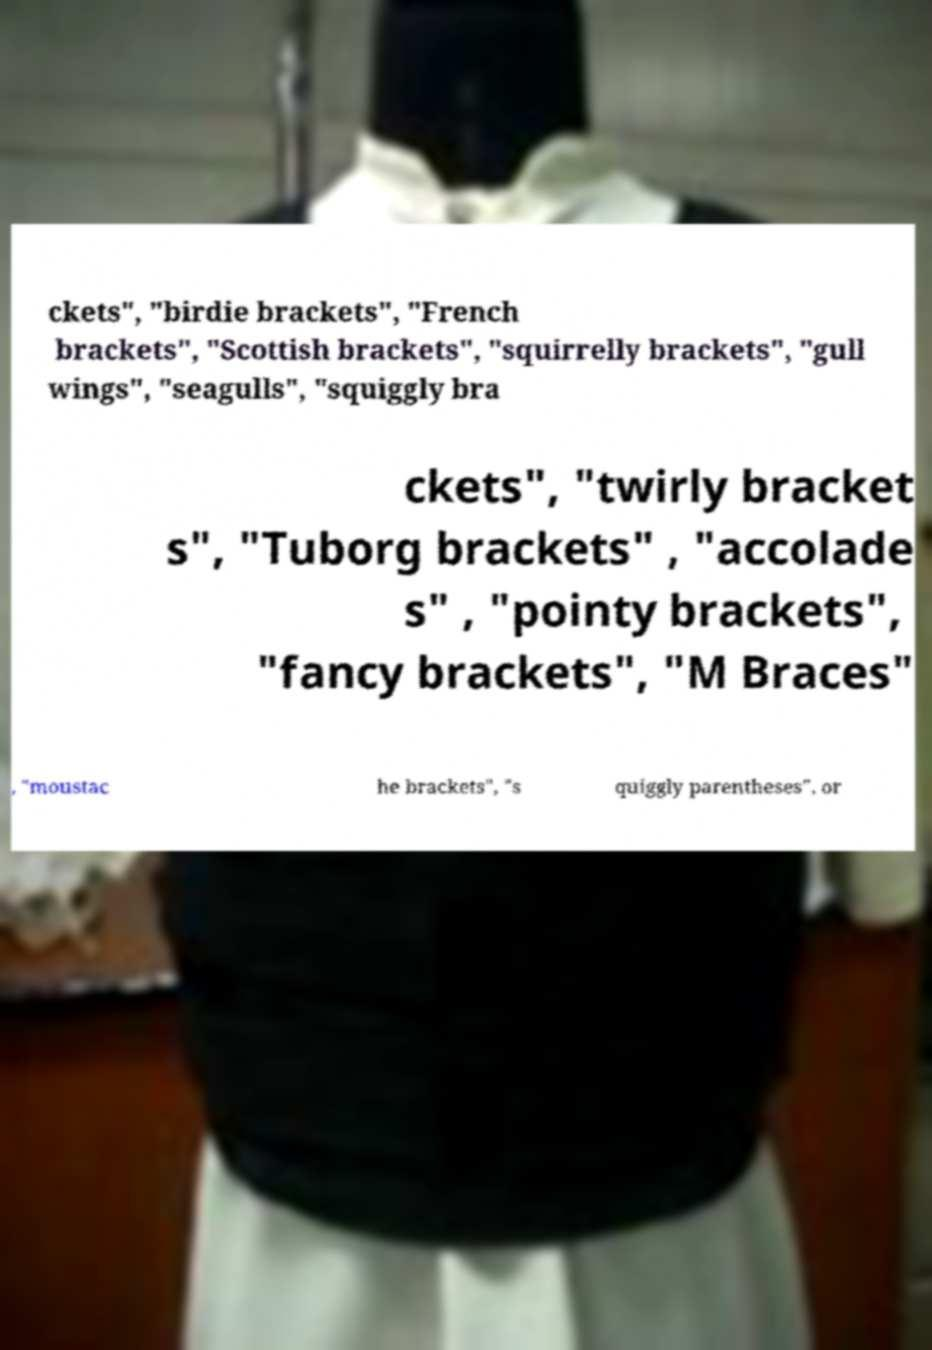What messages or text are displayed in this image? I need them in a readable, typed format. ckets", "birdie brackets", "French brackets", "Scottish brackets", "squirrelly brackets", "gull wings", "seagulls", "squiggly bra ckets", "twirly bracket s", "Tuborg brackets" , "accolade s" , "pointy brackets", "fancy brackets", "M Braces" , "moustac he brackets", "s quiggly parentheses", or 